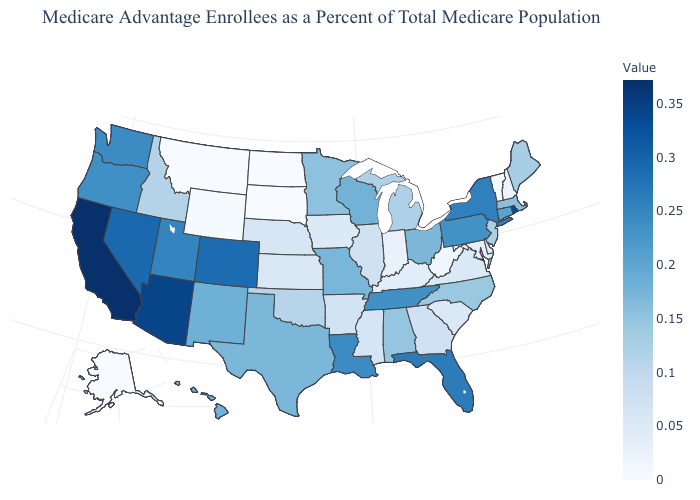Among the states that border Delaware , which have the highest value?
Write a very short answer. Pennsylvania. Does South Dakota have the lowest value in the MidWest?
Concise answer only. No. Which states have the lowest value in the MidWest?
Short answer required. North Dakota. 